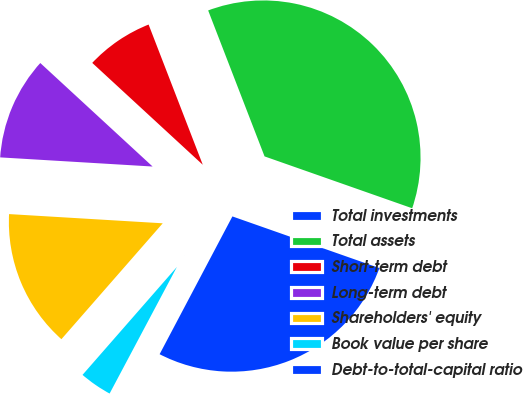Convert chart to OTSL. <chart><loc_0><loc_0><loc_500><loc_500><pie_chart><fcel>Total investments<fcel>Total assets<fcel>Short-term debt<fcel>Long-term debt<fcel>Shareholders' equity<fcel>Book value per share<fcel>Debt-to-total-capital ratio<nl><fcel>27.36%<fcel>36.25%<fcel>7.28%<fcel>10.9%<fcel>14.52%<fcel>3.66%<fcel>0.04%<nl></chart> 